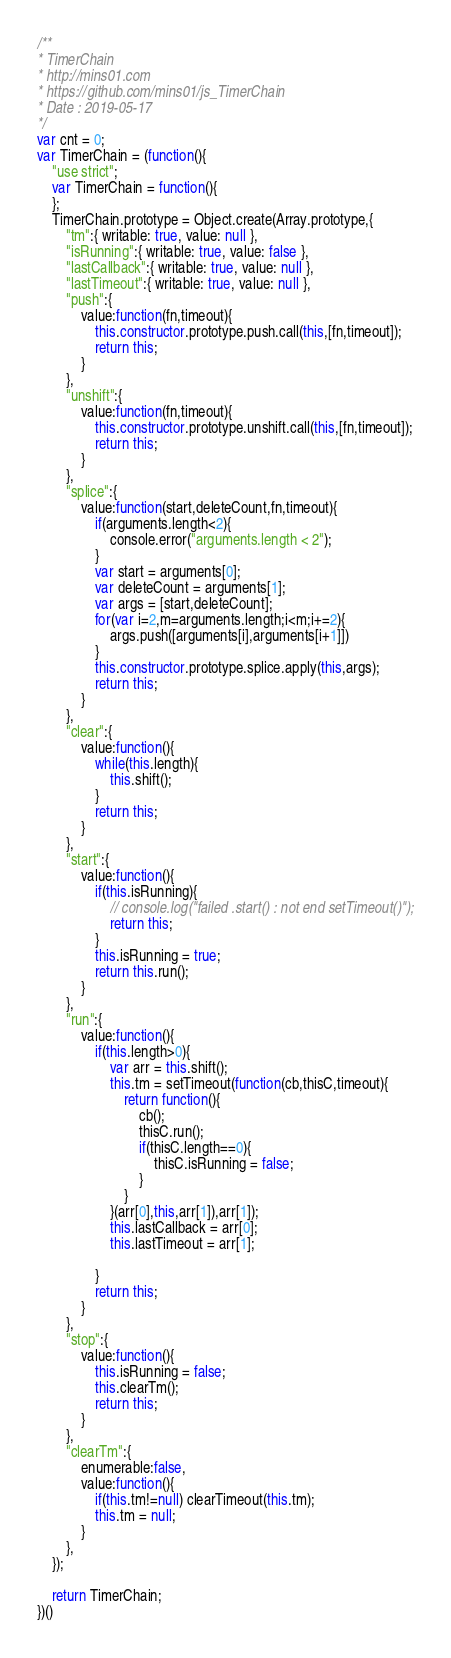Convert code to text. <code><loc_0><loc_0><loc_500><loc_500><_JavaScript_>/**
* TimerChain
* http://mins01.com
* https://github.com/mins01/js_TimerChain
* Date : 2019-05-17
*/
var cnt = 0;
var TimerChain = (function(){
	"use strict";
	var TimerChain = function(){	
	};
	TimerChain.prototype = Object.create(Array.prototype,{
		"tm":{ writable: true, value: null },
		"isRunning":{ writable: true, value: false },
		"lastCallback":{ writable: true, value: null },
		"lastTimeout":{ writable: true, value: null },
		"push":{
			value:function(fn,timeout){
				this.constructor.prototype.push.call(this,[fn,timeout]);
				return this;
			}
		},
		"unshift":{
			value:function(fn,timeout){
				this.constructor.prototype.unshift.call(this,[fn,timeout]);
				return this;
			}
		},
		"splice":{
			value:function(start,deleteCount,fn,timeout){
				if(arguments.length<2){
					console.error("arguments.length < 2");
				}
				var start = arguments[0];
				var deleteCount = arguments[1];
				var args = [start,deleteCount];
				for(var i=2,m=arguments.length;i<m;i+=2){
					args.push([arguments[i],arguments[i+1]])
				}
				this.constructor.prototype.splice.apply(this,args);
				return this;
			}
		},
		"clear":{
			value:function(){
				while(this.length){
					this.shift();
				}
				return this;
			}
		},
		"start":{
			value:function(){
				if(this.isRunning){ 
					// console.log("failed .start() : not end setTimeout()");
					return this;
				}
				this.isRunning = true;
				return this.run();
			}
		},
		"run":{
			value:function(){
				if(this.length>0){
					var arr = this.shift();
					this.tm = setTimeout(function(cb,thisC,timeout){
						return function(){
							cb();
							thisC.run();
							if(thisC.length==0){
								thisC.isRunning = false;
							}
						}
					}(arr[0],this,arr[1]),arr[1]);
					this.lastCallback = arr[0];
					this.lastTimeout = arr[1];

				}
				return this;
			}
		},
		"stop":{
			value:function(){
				this.isRunning = false;
				this.clearTm();
				return this;
			}
		},
		"clearTm":{
			enumerable:false,
			value:function(){
				if(this.tm!=null) clearTimeout(this.tm);
				this.tm = null;
			}
		},
	});
	
	return TimerChain;
})()</code> 